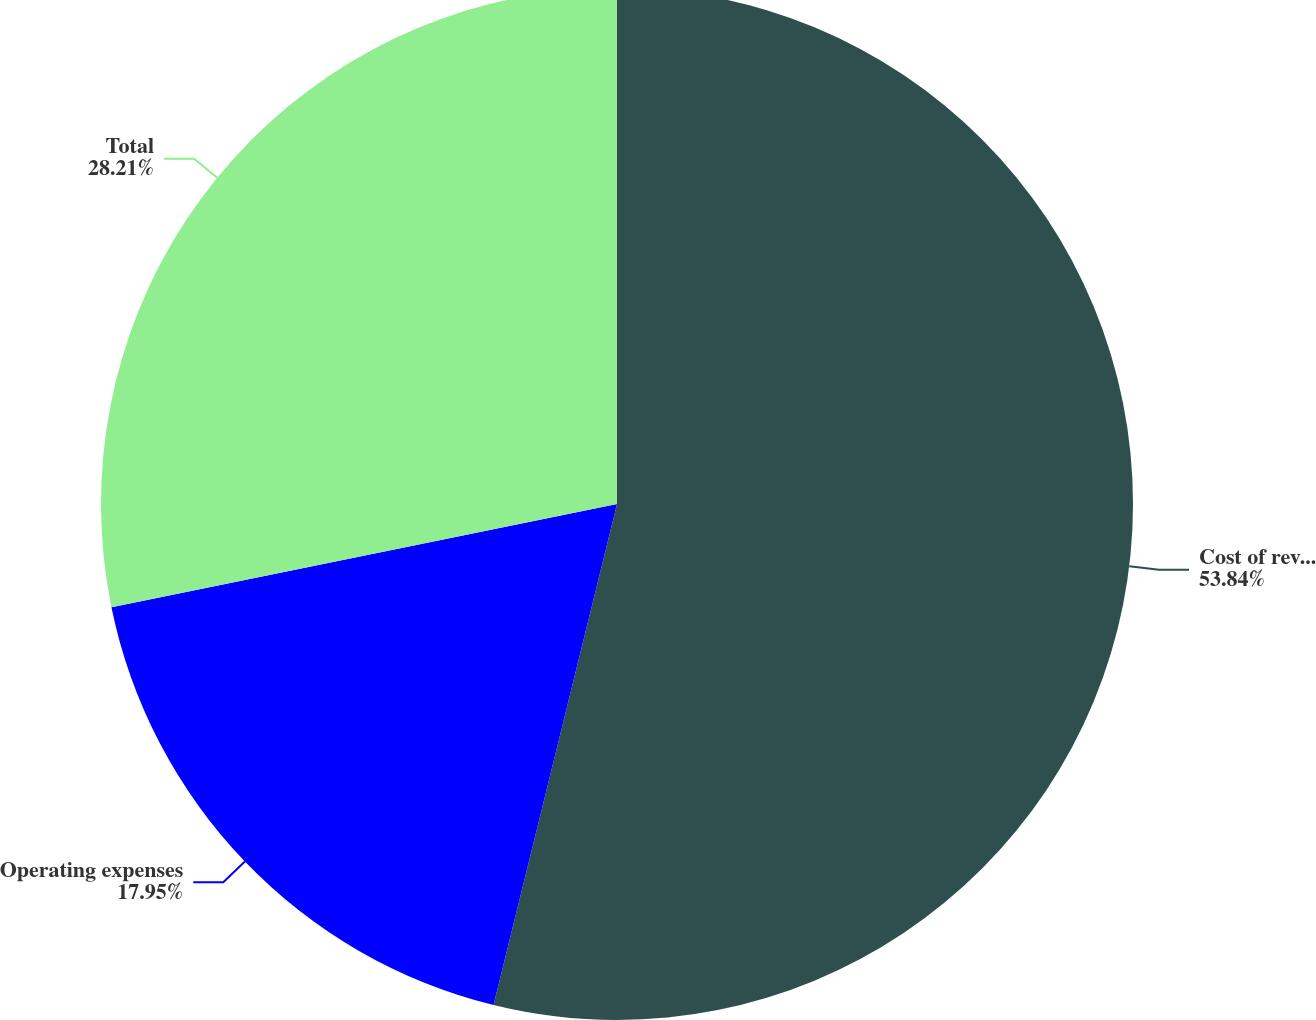Convert chart to OTSL. <chart><loc_0><loc_0><loc_500><loc_500><pie_chart><fcel>Cost of revenue<fcel>Operating expenses<fcel>Total<nl><fcel>53.85%<fcel>17.95%<fcel>28.21%<nl></chart> 